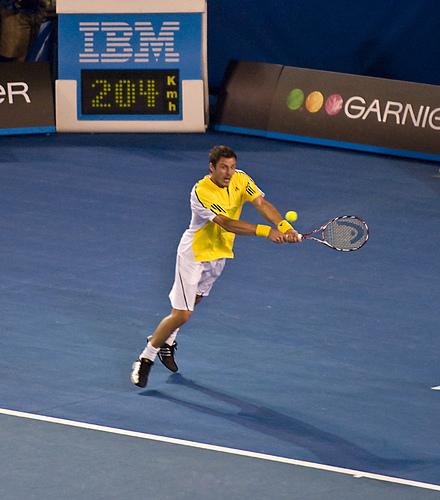What are their sponsors?
Answer briefly. Ibm, garnier. What color is the man's shirt?
Be succinct. Yellow. Which sport is this?
Give a very brief answer. Tennis. 